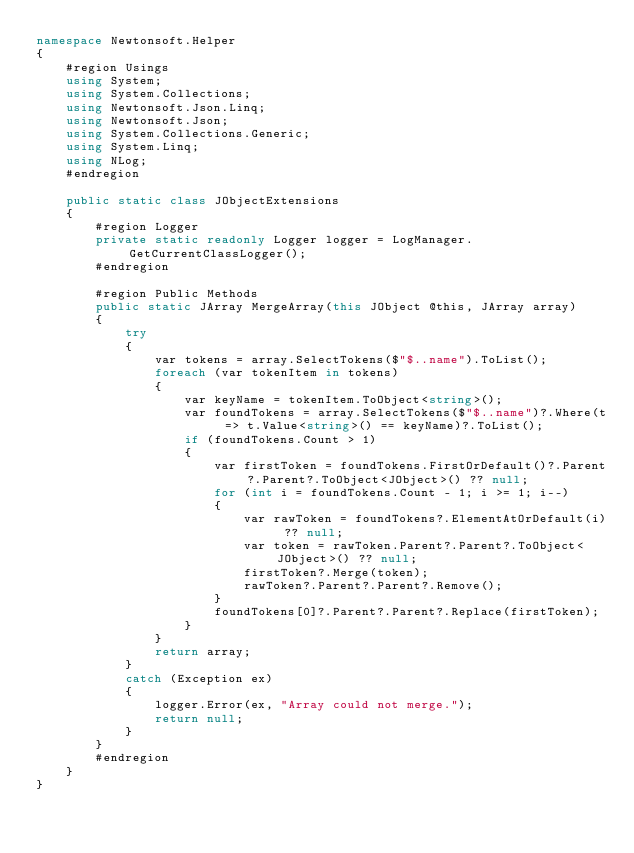<code> <loc_0><loc_0><loc_500><loc_500><_C#_>namespace Newtonsoft.Helper
{
    #region Usings
    using System;
    using System.Collections;
    using Newtonsoft.Json.Linq;
    using Newtonsoft.Json;
    using System.Collections.Generic;
    using System.Linq;
    using NLog;
    #endregion

    public static class JObjectExtensions
    {
        #region Logger
        private static readonly Logger logger = LogManager.GetCurrentClassLogger();
        #endregion

        #region Public Methods
        public static JArray MergeArray(this JObject @this, JArray array)
        {
            try
            {
                var tokens = array.SelectTokens($"$..name").ToList();
                foreach (var tokenItem in tokens)
                {
                    var keyName = tokenItem.ToObject<string>();
                    var foundTokens = array.SelectTokens($"$..name")?.Where(t => t.Value<string>() == keyName)?.ToList();
                    if (foundTokens.Count > 1)
                    {
                        var firstToken = foundTokens.FirstOrDefault()?.Parent?.Parent?.ToObject<JObject>() ?? null;
                        for (int i = foundTokens.Count - 1; i >= 1; i--)
                        {
                            var rawToken = foundTokens?.ElementAtOrDefault(i) ?? null;
                            var token = rawToken.Parent?.Parent?.ToObject<JObject>() ?? null;
                            firstToken?.Merge(token);
                            rawToken?.Parent?.Parent?.Remove();
                        }
                        foundTokens[0]?.Parent?.Parent?.Replace(firstToken);
                    }
                }
                return array;
            }
            catch (Exception ex)
            {
                logger.Error(ex, "Array could not merge.");
                return null;
            }
        }
        #endregion
    }
}</code> 